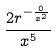<formula> <loc_0><loc_0><loc_500><loc_500>\frac { 2 r ^ { - \frac { 0 } { x ^ { 2 } } } } { x ^ { 5 } }</formula> 